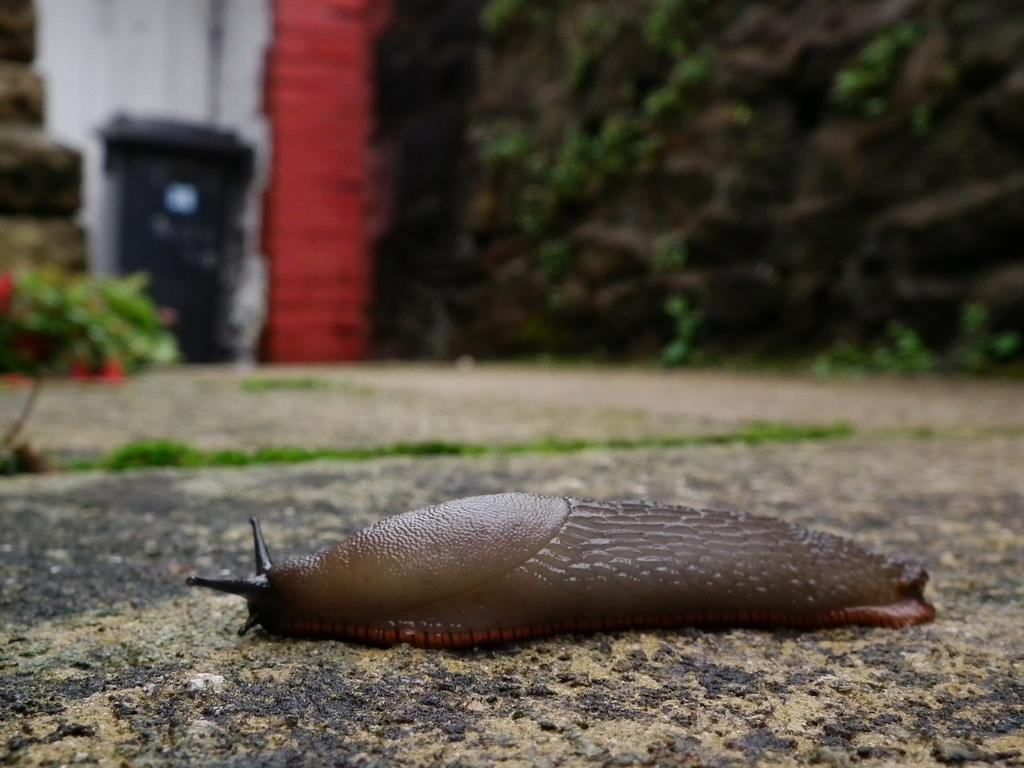What is on the ground in the image? There is an insect on the ground in the image. What can be seen in the distance in the image? There are trees and a plant in the background of the image. What type of vegetation is on the ground in the background of the image? There is grass on the ground in the background of the image. How is the background of the image depicted? The background of the image is blurred. What type of map is visible in the image? There is no map present in the image. What kind of carriage can be seen in the background of the image? There is no carriage present in the image. 